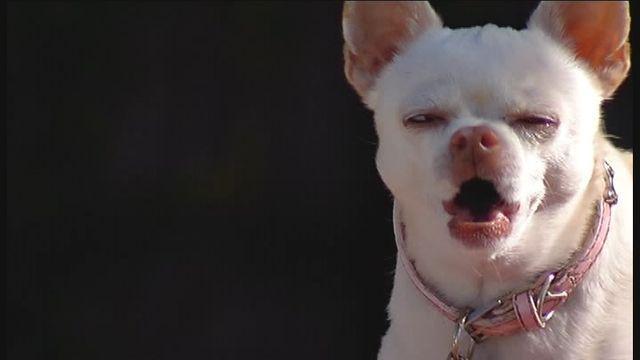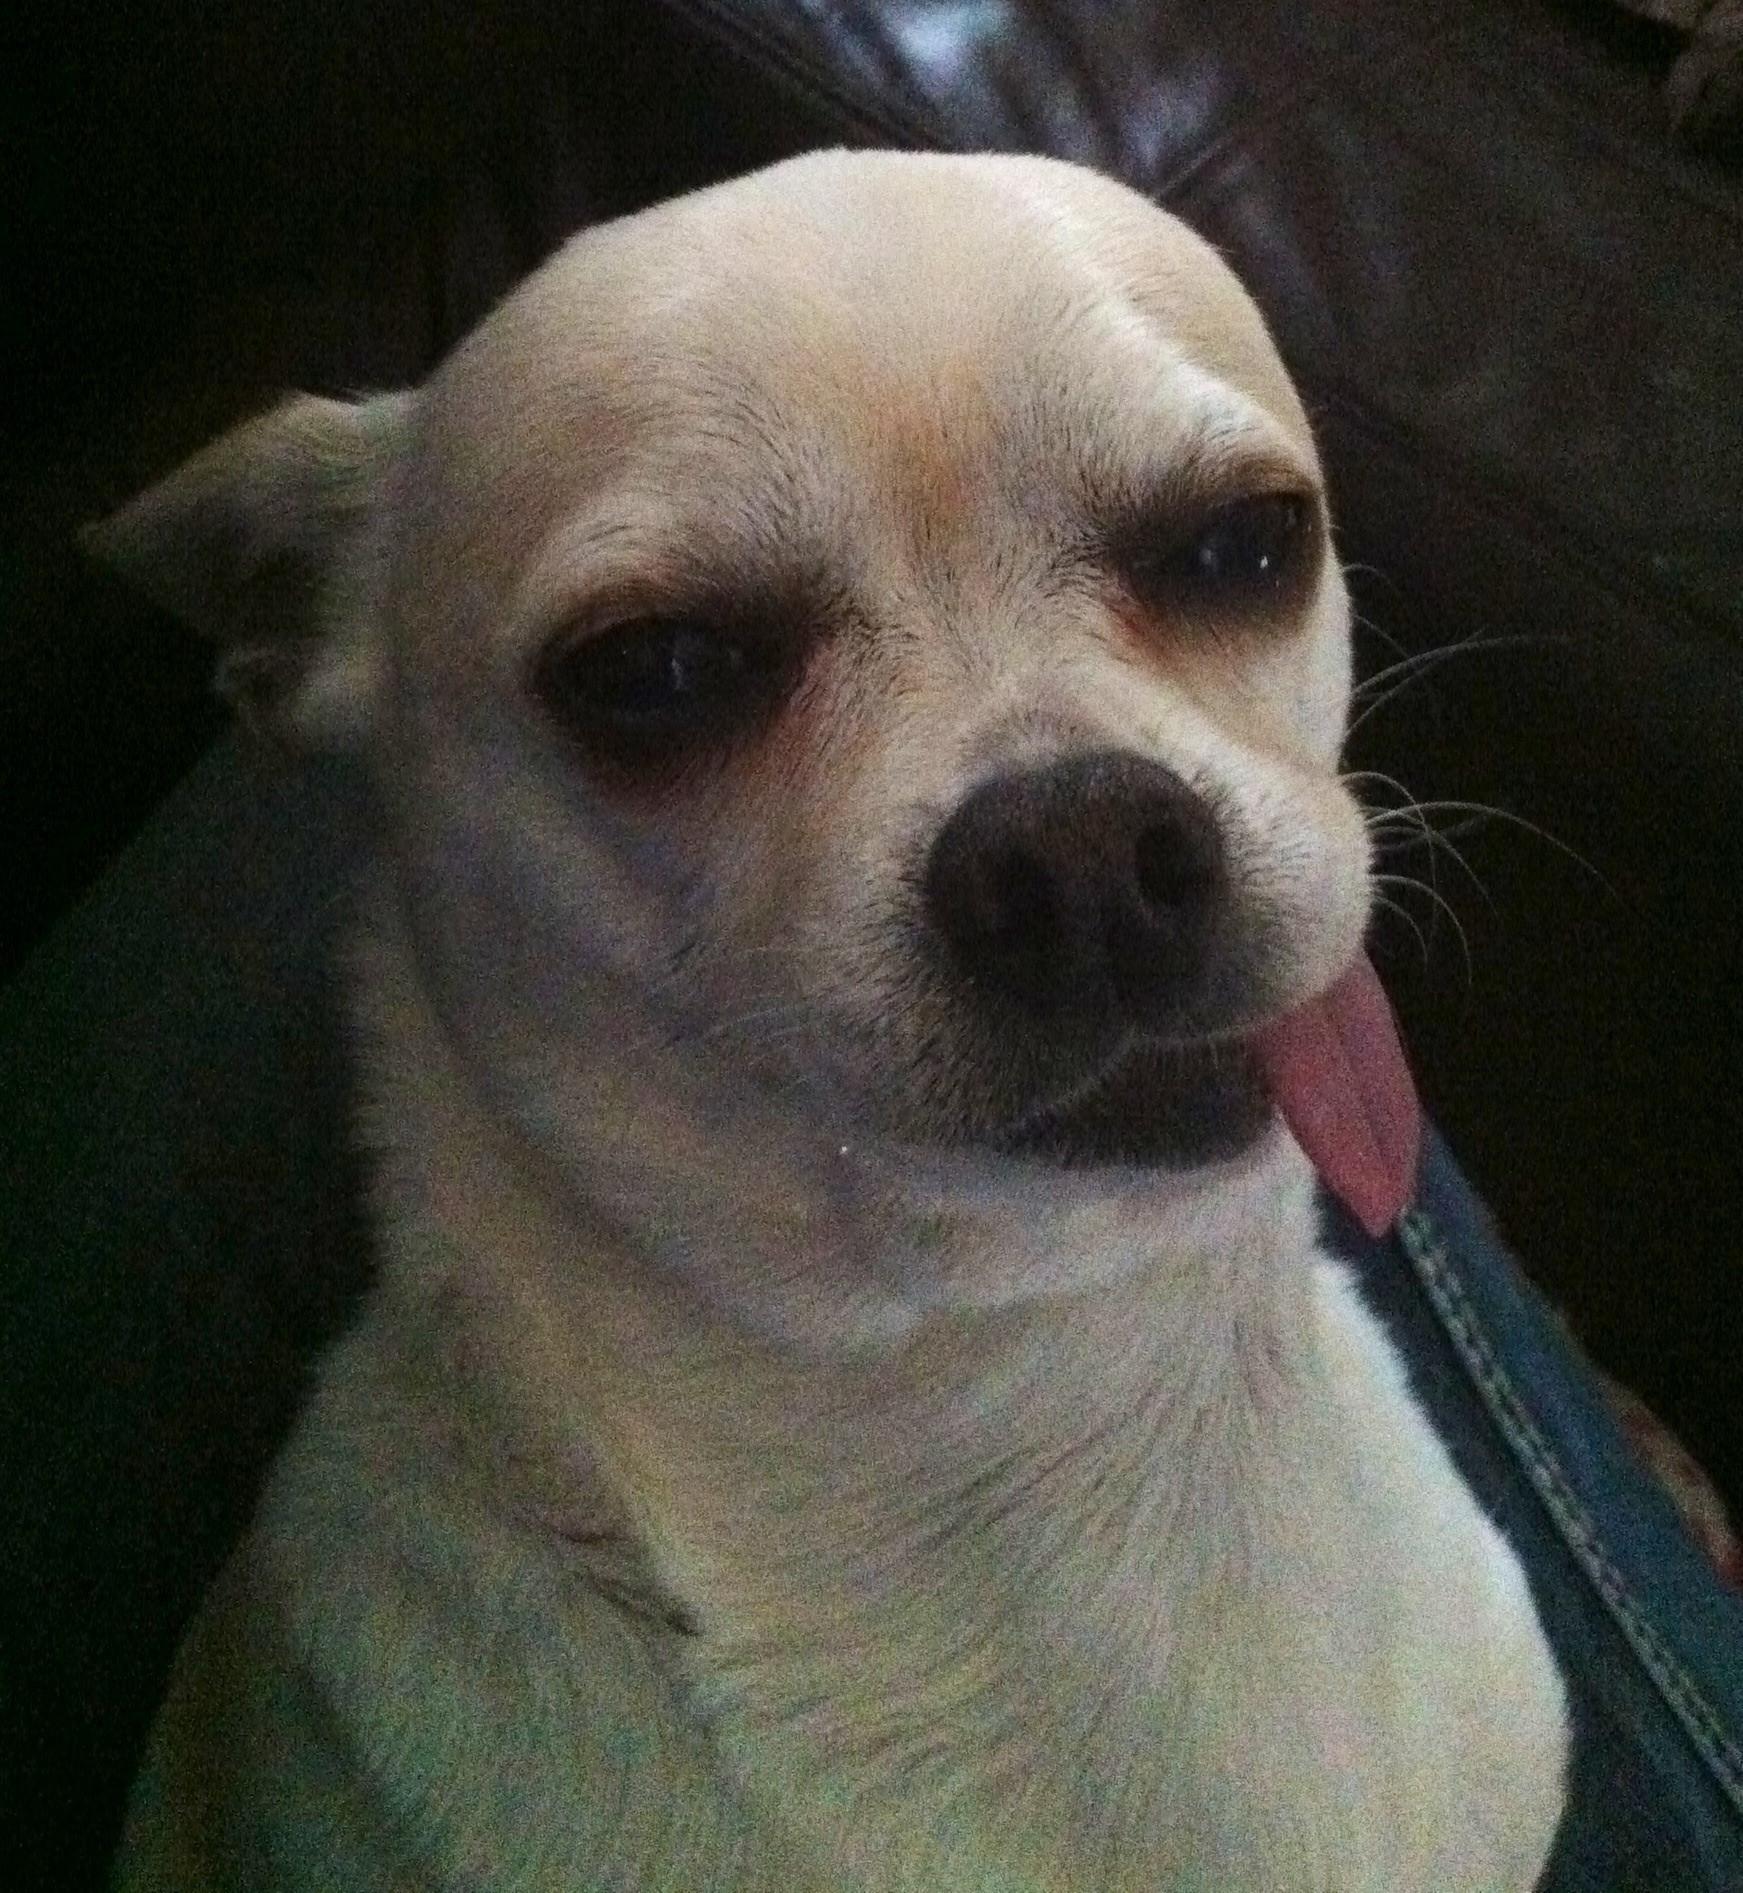The first image is the image on the left, the second image is the image on the right. Analyze the images presented: Is the assertion "One of the dogs in one of the images is baring its teeth." valid? Answer yes or no. No. 